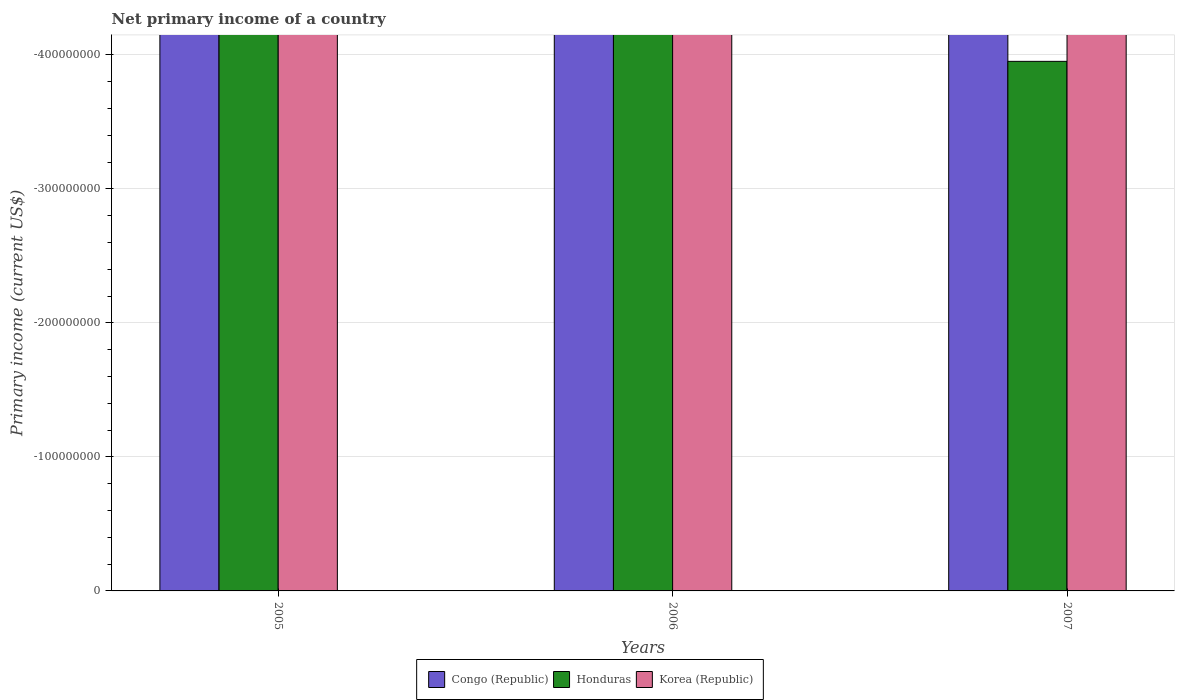How many different coloured bars are there?
Your response must be concise. 0. What is the label of the 2nd group of bars from the left?
Provide a short and direct response. 2006. Across all years, what is the minimum primary income in Honduras?
Provide a succinct answer. 0. What is the difference between the primary income in Congo (Republic) in 2007 and the primary income in Honduras in 2005?
Ensure brevity in your answer.  0. In how many years, is the primary income in Congo (Republic) greater than -20000000 US$?
Your answer should be very brief. 0. In how many years, is the primary income in Congo (Republic) greater than the average primary income in Congo (Republic) taken over all years?
Provide a succinct answer. 0. How many bars are there?
Offer a terse response. 0. Are all the bars in the graph horizontal?
Make the answer very short. No. How many years are there in the graph?
Provide a short and direct response. 3. What is the difference between two consecutive major ticks on the Y-axis?
Your answer should be very brief. 1.00e+08. Does the graph contain any zero values?
Give a very brief answer. Yes. Where does the legend appear in the graph?
Give a very brief answer. Bottom center. What is the title of the graph?
Ensure brevity in your answer.  Net primary income of a country. What is the label or title of the X-axis?
Your answer should be very brief. Years. What is the label or title of the Y-axis?
Your answer should be very brief. Primary income (current US$). What is the Primary income (current US$) of Honduras in 2005?
Make the answer very short. 0. What is the Primary income (current US$) of Korea (Republic) in 2005?
Provide a short and direct response. 0. What is the Primary income (current US$) of Congo (Republic) in 2006?
Ensure brevity in your answer.  0. What is the Primary income (current US$) in Honduras in 2007?
Provide a short and direct response. 0. What is the total Primary income (current US$) of Honduras in the graph?
Ensure brevity in your answer.  0. What is the average Primary income (current US$) of Congo (Republic) per year?
Ensure brevity in your answer.  0. What is the average Primary income (current US$) in Honduras per year?
Your response must be concise. 0. What is the average Primary income (current US$) in Korea (Republic) per year?
Give a very brief answer. 0. 